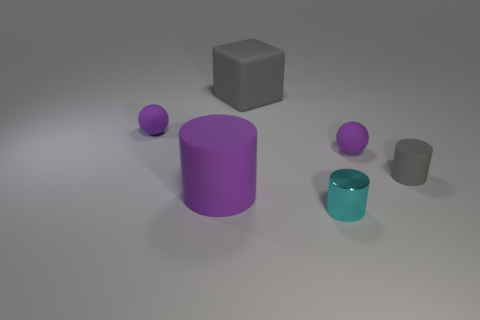Add 1 gray matte things. How many objects exist? 7 Subtract all spheres. How many objects are left? 4 Add 4 cubes. How many cubes are left? 5 Add 5 tiny cylinders. How many tiny cylinders exist? 7 Subtract 0 brown cylinders. How many objects are left? 6 Subtract all cyan spheres. Subtract all cyan metal cylinders. How many objects are left? 5 